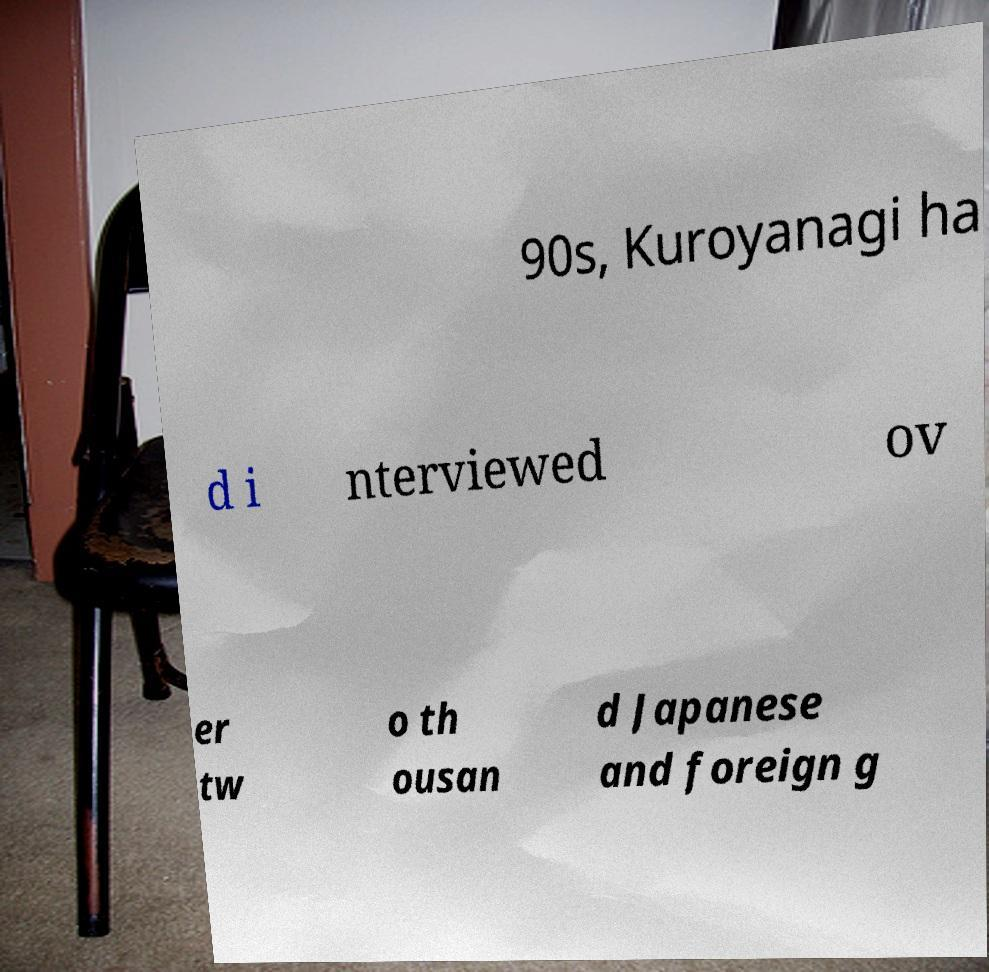I need the written content from this picture converted into text. Can you do that? 90s, Kuroyanagi ha d i nterviewed ov er tw o th ousan d Japanese and foreign g 